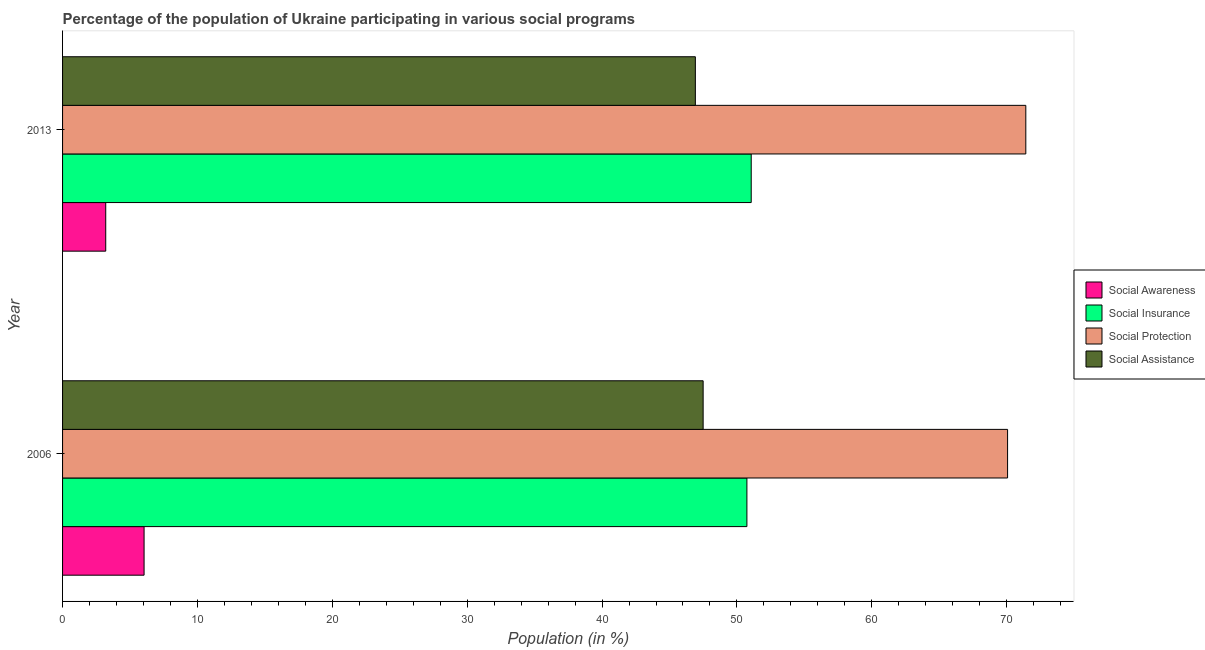How many groups of bars are there?
Provide a succinct answer. 2. Are the number of bars per tick equal to the number of legend labels?
Your answer should be very brief. Yes. Are the number of bars on each tick of the Y-axis equal?
Make the answer very short. Yes. What is the label of the 2nd group of bars from the top?
Offer a terse response. 2006. In how many cases, is the number of bars for a given year not equal to the number of legend labels?
Your answer should be very brief. 0. What is the participation of population in social insurance programs in 2006?
Your answer should be compact. 50.74. Across all years, what is the maximum participation of population in social protection programs?
Make the answer very short. 71.42. Across all years, what is the minimum participation of population in social protection programs?
Keep it short and to the point. 70.07. In which year was the participation of population in social awareness programs maximum?
Keep it short and to the point. 2006. In which year was the participation of population in social insurance programs minimum?
Make the answer very short. 2006. What is the total participation of population in social awareness programs in the graph?
Your answer should be compact. 9.24. What is the difference between the participation of population in social assistance programs in 2006 and that in 2013?
Your response must be concise. 0.58. What is the difference between the participation of population in social insurance programs in 2006 and the participation of population in social protection programs in 2013?
Ensure brevity in your answer.  -20.68. What is the average participation of population in social protection programs per year?
Make the answer very short. 70.74. In the year 2013, what is the difference between the participation of population in social assistance programs and participation of population in social insurance programs?
Your answer should be compact. -4.14. In how many years, is the participation of population in social assistance programs greater than 26 %?
Offer a terse response. 2. What is the ratio of the participation of population in social protection programs in 2006 to that in 2013?
Provide a succinct answer. 0.98. Is the participation of population in social insurance programs in 2006 less than that in 2013?
Your answer should be very brief. Yes. In how many years, is the participation of population in social assistance programs greater than the average participation of population in social assistance programs taken over all years?
Make the answer very short. 1. What does the 2nd bar from the top in 2006 represents?
Offer a terse response. Social Protection. What does the 1st bar from the bottom in 2006 represents?
Provide a short and direct response. Social Awareness. Is it the case that in every year, the sum of the participation of population in social awareness programs and participation of population in social insurance programs is greater than the participation of population in social protection programs?
Your answer should be compact. No. Are all the bars in the graph horizontal?
Your answer should be compact. Yes. How many years are there in the graph?
Your answer should be very brief. 2. Are the values on the major ticks of X-axis written in scientific E-notation?
Ensure brevity in your answer.  No. Does the graph contain grids?
Provide a succinct answer. No. Where does the legend appear in the graph?
Provide a succinct answer. Center right. What is the title of the graph?
Offer a terse response. Percentage of the population of Ukraine participating in various social programs . Does "Macroeconomic management" appear as one of the legend labels in the graph?
Keep it short and to the point. No. What is the Population (in %) in Social Awareness in 2006?
Offer a terse response. 6.04. What is the Population (in %) of Social Insurance in 2006?
Your answer should be compact. 50.74. What is the Population (in %) in Social Protection in 2006?
Give a very brief answer. 70.07. What is the Population (in %) in Social Assistance in 2006?
Give a very brief answer. 47.5. What is the Population (in %) of Social Awareness in 2013?
Provide a succinct answer. 3.2. What is the Population (in %) of Social Insurance in 2013?
Your response must be concise. 51.06. What is the Population (in %) of Social Protection in 2013?
Keep it short and to the point. 71.42. What is the Population (in %) in Social Assistance in 2013?
Ensure brevity in your answer.  46.92. Across all years, what is the maximum Population (in %) of Social Awareness?
Offer a terse response. 6.04. Across all years, what is the maximum Population (in %) of Social Insurance?
Offer a terse response. 51.06. Across all years, what is the maximum Population (in %) of Social Protection?
Ensure brevity in your answer.  71.42. Across all years, what is the maximum Population (in %) in Social Assistance?
Provide a succinct answer. 47.5. Across all years, what is the minimum Population (in %) in Social Awareness?
Provide a short and direct response. 3.2. Across all years, what is the minimum Population (in %) of Social Insurance?
Offer a very short reply. 50.74. Across all years, what is the minimum Population (in %) of Social Protection?
Your response must be concise. 70.07. Across all years, what is the minimum Population (in %) in Social Assistance?
Your answer should be very brief. 46.92. What is the total Population (in %) in Social Awareness in the graph?
Give a very brief answer. 9.24. What is the total Population (in %) of Social Insurance in the graph?
Keep it short and to the point. 101.8. What is the total Population (in %) of Social Protection in the graph?
Provide a succinct answer. 141.49. What is the total Population (in %) in Social Assistance in the graph?
Keep it short and to the point. 94.41. What is the difference between the Population (in %) in Social Awareness in 2006 and that in 2013?
Your response must be concise. 2.84. What is the difference between the Population (in %) in Social Insurance in 2006 and that in 2013?
Offer a very short reply. -0.32. What is the difference between the Population (in %) in Social Protection in 2006 and that in 2013?
Offer a very short reply. -1.35. What is the difference between the Population (in %) in Social Assistance in 2006 and that in 2013?
Your answer should be compact. 0.58. What is the difference between the Population (in %) of Social Awareness in 2006 and the Population (in %) of Social Insurance in 2013?
Provide a succinct answer. -45.01. What is the difference between the Population (in %) in Social Awareness in 2006 and the Population (in %) in Social Protection in 2013?
Make the answer very short. -65.38. What is the difference between the Population (in %) in Social Awareness in 2006 and the Population (in %) in Social Assistance in 2013?
Your response must be concise. -40.87. What is the difference between the Population (in %) of Social Insurance in 2006 and the Population (in %) of Social Protection in 2013?
Provide a short and direct response. -20.68. What is the difference between the Population (in %) of Social Insurance in 2006 and the Population (in %) of Social Assistance in 2013?
Your answer should be very brief. 3.82. What is the difference between the Population (in %) in Social Protection in 2006 and the Population (in %) in Social Assistance in 2013?
Provide a short and direct response. 23.15. What is the average Population (in %) of Social Awareness per year?
Ensure brevity in your answer.  4.62. What is the average Population (in %) in Social Insurance per year?
Make the answer very short. 50.9. What is the average Population (in %) in Social Protection per year?
Your answer should be very brief. 70.74. What is the average Population (in %) in Social Assistance per year?
Offer a terse response. 47.21. In the year 2006, what is the difference between the Population (in %) of Social Awareness and Population (in %) of Social Insurance?
Keep it short and to the point. -44.7. In the year 2006, what is the difference between the Population (in %) of Social Awareness and Population (in %) of Social Protection?
Your answer should be compact. -64.02. In the year 2006, what is the difference between the Population (in %) in Social Awareness and Population (in %) in Social Assistance?
Give a very brief answer. -41.45. In the year 2006, what is the difference between the Population (in %) of Social Insurance and Population (in %) of Social Protection?
Offer a terse response. -19.33. In the year 2006, what is the difference between the Population (in %) of Social Insurance and Population (in %) of Social Assistance?
Provide a short and direct response. 3.24. In the year 2006, what is the difference between the Population (in %) of Social Protection and Population (in %) of Social Assistance?
Ensure brevity in your answer.  22.57. In the year 2013, what is the difference between the Population (in %) in Social Awareness and Population (in %) in Social Insurance?
Your answer should be very brief. -47.86. In the year 2013, what is the difference between the Population (in %) of Social Awareness and Population (in %) of Social Protection?
Make the answer very short. -68.22. In the year 2013, what is the difference between the Population (in %) of Social Awareness and Population (in %) of Social Assistance?
Give a very brief answer. -43.72. In the year 2013, what is the difference between the Population (in %) of Social Insurance and Population (in %) of Social Protection?
Make the answer very short. -20.36. In the year 2013, what is the difference between the Population (in %) in Social Insurance and Population (in %) in Social Assistance?
Provide a short and direct response. 4.14. In the year 2013, what is the difference between the Population (in %) of Social Protection and Population (in %) of Social Assistance?
Ensure brevity in your answer.  24.5. What is the ratio of the Population (in %) in Social Awareness in 2006 to that in 2013?
Give a very brief answer. 1.89. What is the ratio of the Population (in %) in Social Insurance in 2006 to that in 2013?
Offer a terse response. 0.99. What is the ratio of the Population (in %) in Social Protection in 2006 to that in 2013?
Provide a succinct answer. 0.98. What is the ratio of the Population (in %) in Social Assistance in 2006 to that in 2013?
Your response must be concise. 1.01. What is the difference between the highest and the second highest Population (in %) in Social Awareness?
Your answer should be compact. 2.84. What is the difference between the highest and the second highest Population (in %) of Social Insurance?
Offer a terse response. 0.32. What is the difference between the highest and the second highest Population (in %) of Social Protection?
Provide a short and direct response. 1.35. What is the difference between the highest and the second highest Population (in %) in Social Assistance?
Your answer should be compact. 0.58. What is the difference between the highest and the lowest Population (in %) of Social Awareness?
Offer a very short reply. 2.84. What is the difference between the highest and the lowest Population (in %) in Social Insurance?
Offer a terse response. 0.32. What is the difference between the highest and the lowest Population (in %) of Social Protection?
Your answer should be very brief. 1.35. What is the difference between the highest and the lowest Population (in %) in Social Assistance?
Offer a very short reply. 0.58. 